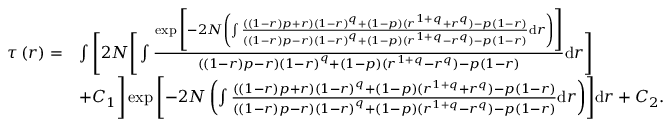<formula> <loc_0><loc_0><loc_500><loc_500>\begin{array} { r l } { \tau \left ( r \right ) = } & { \int \left [ 2 N \left [ \int \frac { \exp \left [ { - 2 N \left ( \int \frac { \left ( \left ( 1 - r \right ) p + r \right ) \left ( 1 - r \right ) ^ { q } + \left ( 1 - p \right ) ( r ^ { 1 + q } + r ^ { q } ) - p \left ( 1 - r \right ) } { \left ( \left ( 1 - r \right ) p - r \right ) \left ( 1 - r \right ) ^ { q } + \left ( 1 - p \right ) ( r ^ { 1 + q } - r ^ { q } ) - p \left ( 1 - r \right ) } d r \right ) } \right ] } { \left ( \left ( 1 - r \right ) p - r \right ) \left ( 1 - r \right ) ^ { q } + \left ( 1 - p \right ) ( r ^ { 1 + q } - r ^ { q } ) - p \left ( 1 - r \right ) } d r \right ] } \\ & { + C _ { 1 } \right ] \exp \left [ { - 2 N \left ( \int \frac { \left ( \left ( 1 - r \right ) p + r \right ) \left ( 1 - r \right ) ^ { q } + \left ( 1 - p \right ) ( r ^ { 1 + q } + r ^ { q } ) - p \left ( 1 - r \right ) } { \left ( \left ( 1 - r \right ) p - r \right ) \left ( 1 - r \right ) ^ { q } + \left ( 1 - p \right ) ( r ^ { 1 + q } - r ^ { q } ) - p \left ( 1 - r \right ) } d r \right ) } \right ] d r + C _ { 2 } . } \end{array}</formula> 